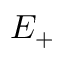Convert formula to latex. <formula><loc_0><loc_0><loc_500><loc_500>E _ { + }</formula> 